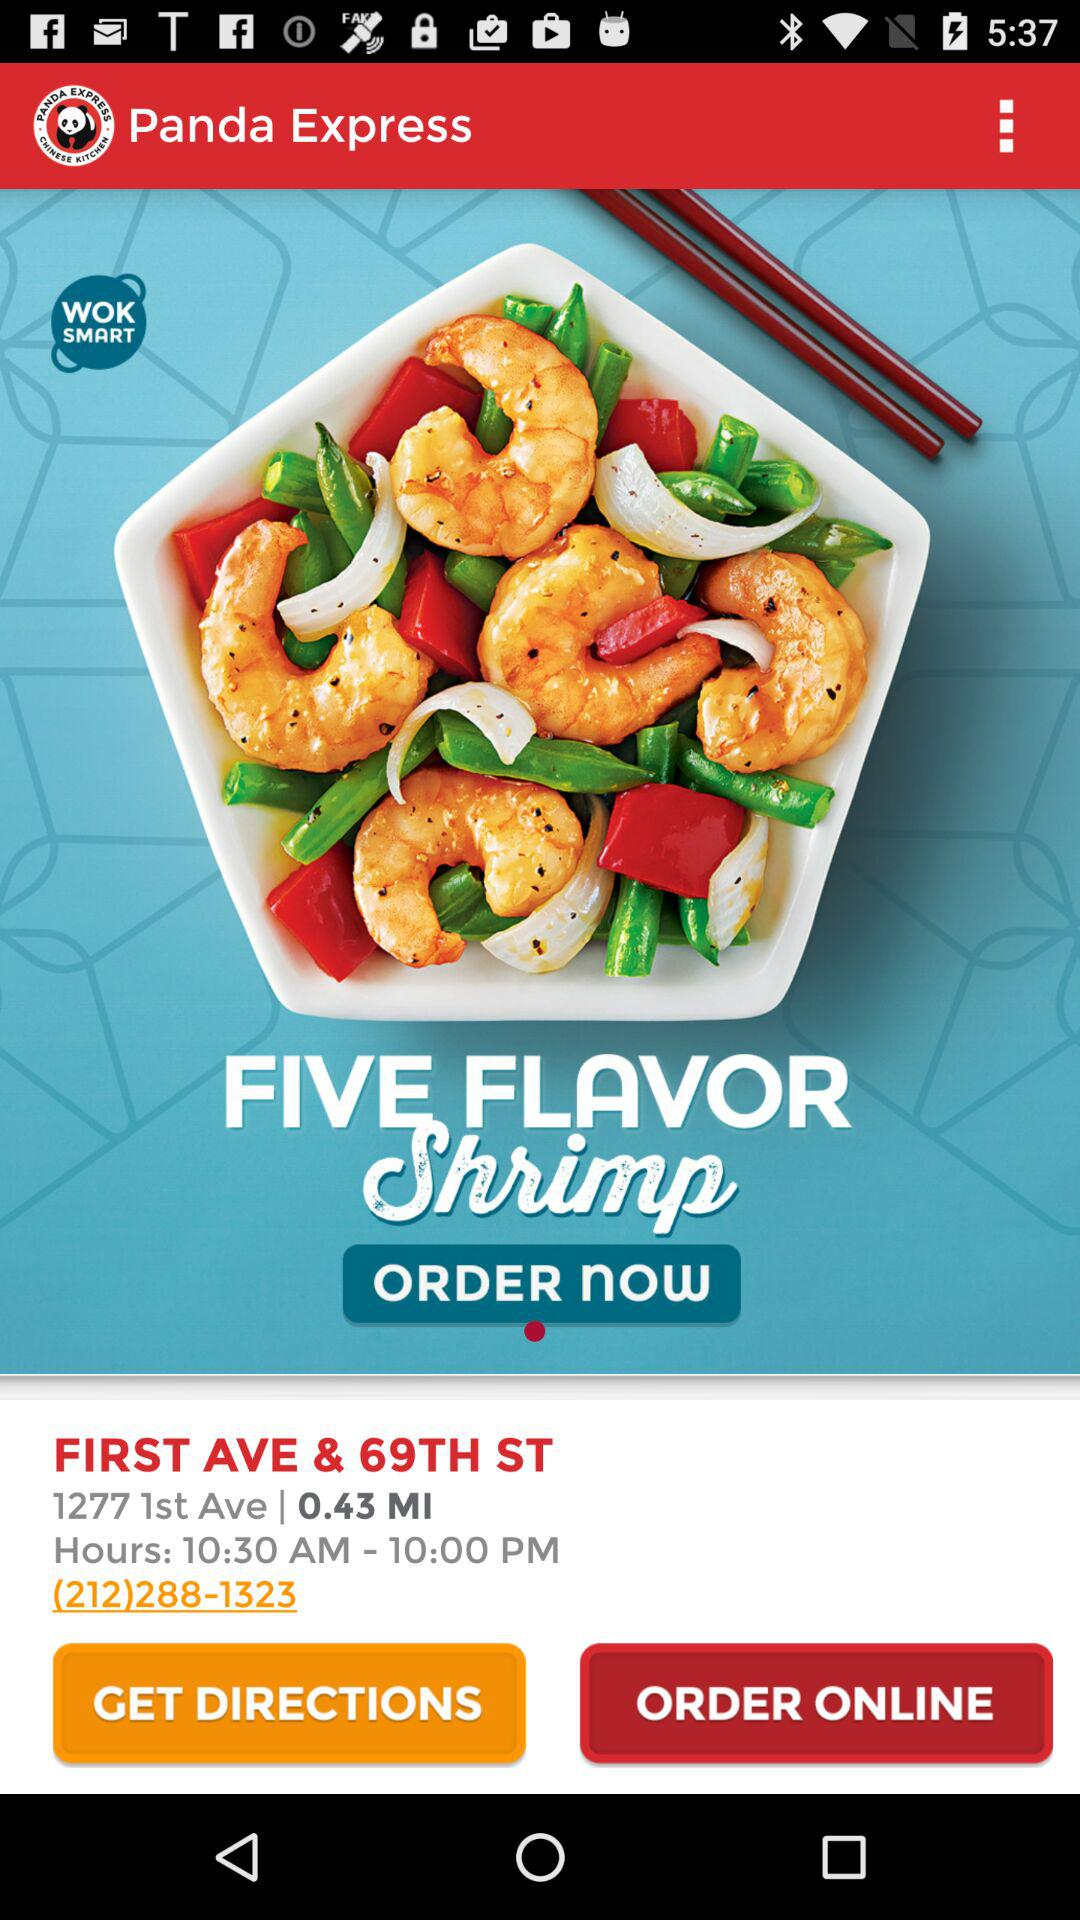What are the opening hours? The opening hours are from 10:30 a.m. to 10:00 p.m. 